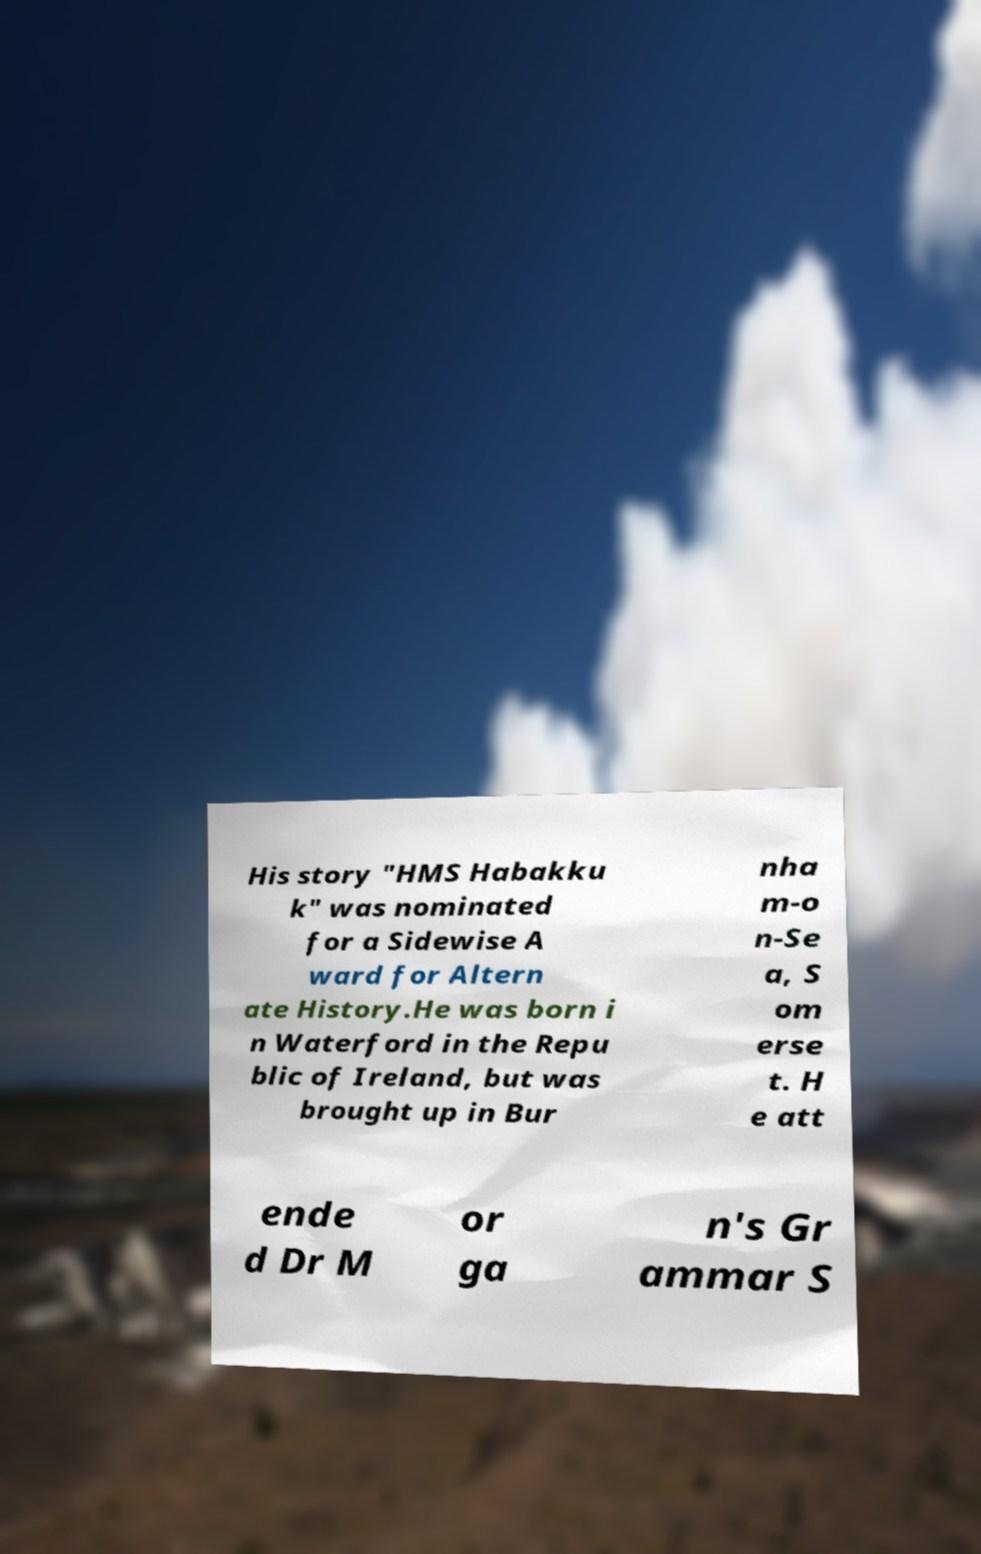I need the written content from this picture converted into text. Can you do that? His story "HMS Habakku k" was nominated for a Sidewise A ward for Altern ate History.He was born i n Waterford in the Repu blic of Ireland, but was brought up in Bur nha m-o n-Se a, S om erse t. H e att ende d Dr M or ga n's Gr ammar S 